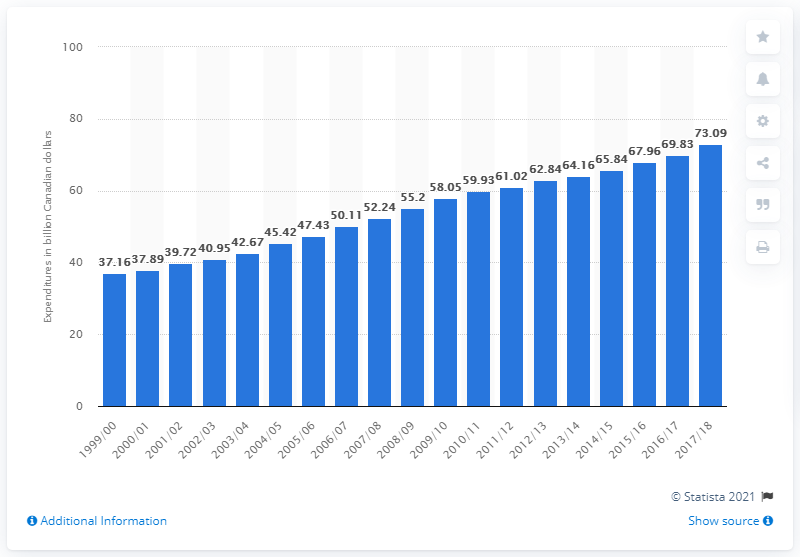Give some essential details in this illustration. In the 2017/2018 school year, Canadian public elementary and secondary schools spent approximately CAD 73.09 per student. 